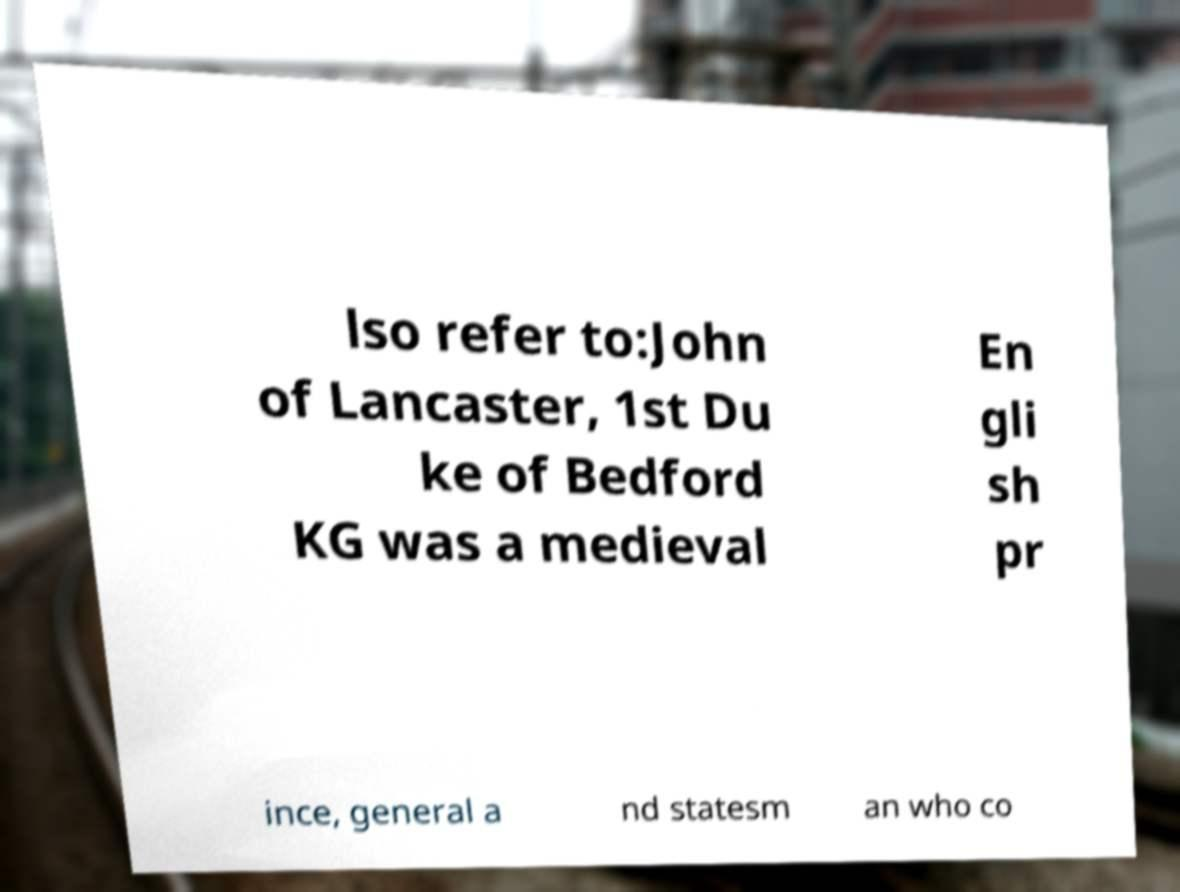Could you assist in decoding the text presented in this image and type it out clearly? lso refer to:John of Lancaster, 1st Du ke of Bedford KG was a medieval En gli sh pr ince, general a nd statesm an who co 